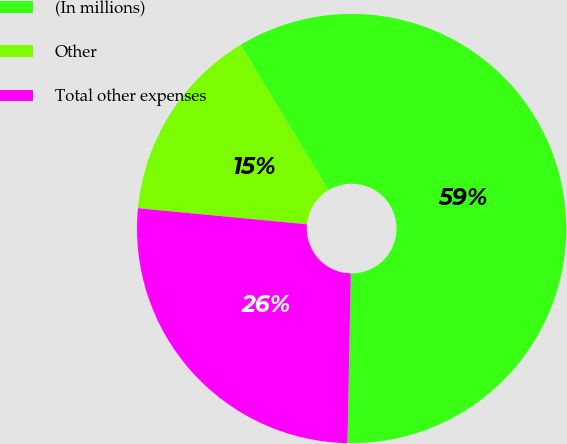<chart> <loc_0><loc_0><loc_500><loc_500><pie_chart><fcel>(In millions)<fcel>Other<fcel>Total other expenses<nl><fcel>58.97%<fcel>14.83%<fcel>26.2%<nl></chart> 